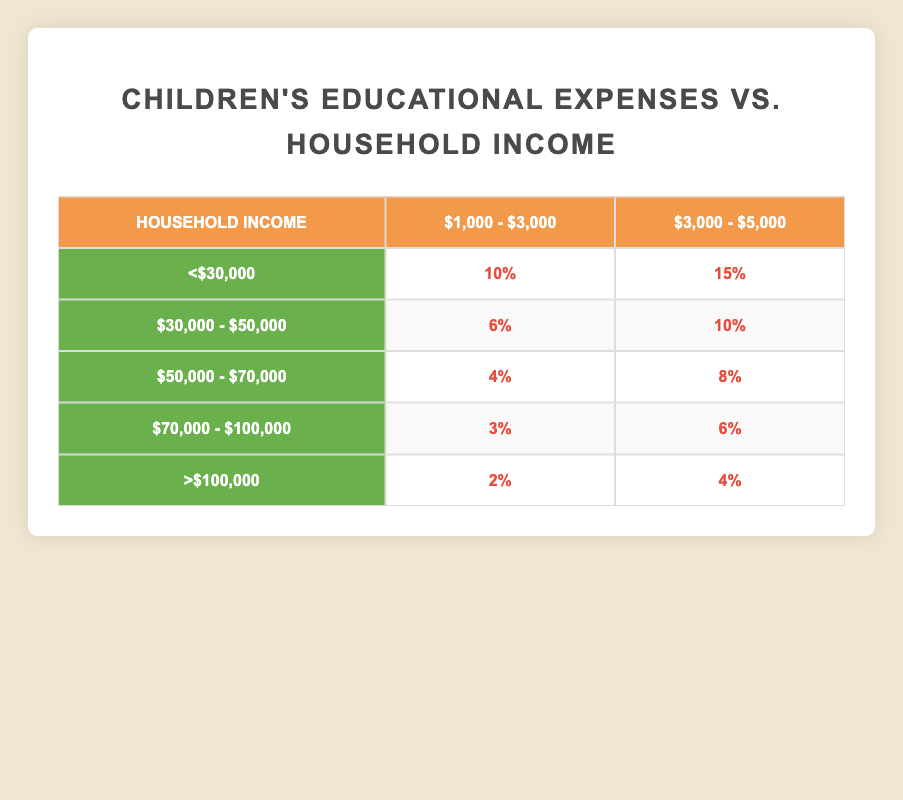What percentage of income is spent on children's education by households earning less than $30,000 for education expenses between $1,000 and $3,000? According to the table, for households earning less than $30,000, the percentage of income spent on education expenses of $1,000 - $3,000 is 10%.
Answer: 10% What is the percentage of income spent on education when households earn between $50,000 and $70,000 for expenses of $3,000 to $5,000? The table indicates that for households earning between $50,000 and $70,000, the percentage for education expenses of $3,000 - $5,000 is 8%.
Answer: 8% Is the percentage of income spent on education higher for households earning between $30,000 and $50,000 compared to those earning between $70,000 and $100,000? For households earning $30,000 - $50,000, the percentages are 6% and 10%, while for those earning $70,000 - $100,000, the percentages are 3% and 6%. The average for the former is 8%, which is higher than the 4.5% average for the latter. Thus, yes, it is higher.
Answer: Yes What is the total percentage of income spent on education expenses across all households with an income of less than $30,000? For households earning less than $30,000, the table shows 10% + 15% = 25% spent on education expenses. Therefore, the total percentage is 25%.
Answer: 25% Which income group spends the least percentage of their income on children's education for expenses between $1,000 and $3,000? The table shows that the income group of >$100,000 spends the least on education expenses of $1,000 - $3,000, with a percentage of 2%.
Answer: >$100,000 How much more does a household with an income of $30,000 - $50,000 spend on education compared to a household earning $50,000 - $70,000, when looking at the percentage of income spent for the $3,000 - $5,000 bracket? For the $3,000 - $5,000 expenses, the percentage for $30,000 - $50,000 is 10%, while for $50,000 - $70,000 it is 8%. Thus, the difference is 10% - 8% = 2%.
Answer: 2% Do households earning over $100,000 spend more than families earning between $70,000 and $100,000 on education expenses between $3,000 and $5,000? Households earning over $100,000 spend 4% on education expenses of $3,000 - $5,000, while those earning between $70,000 - $100,000 spend 6%. Since 6% > 4%, the answer is no.
Answer: No 